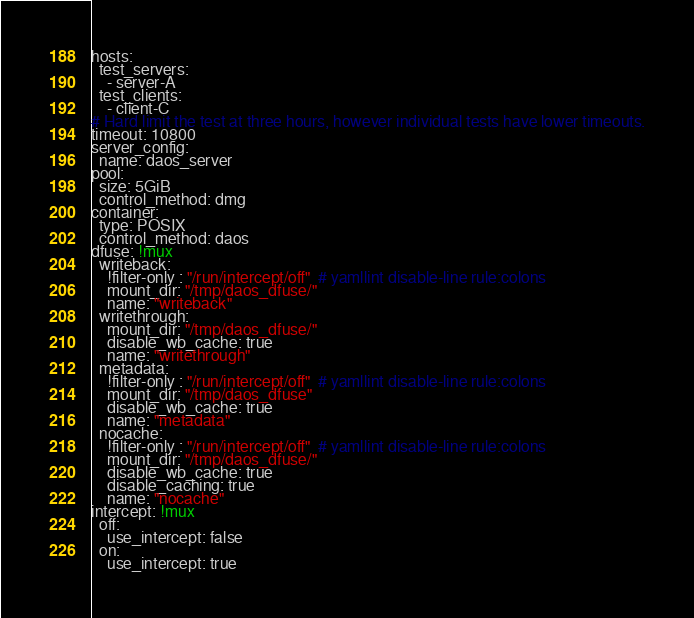Convert code to text. <code><loc_0><loc_0><loc_500><loc_500><_YAML_>hosts:
  test_servers:
    - server-A
  test_clients:
    - client-C
# Hard limit the test at three hours, however individual tests have lower timeouts.
timeout: 10800
server_config:
  name: daos_server
pool:
  size: 5GiB
  control_method: dmg
container:
  type: POSIX
  control_method: daos
dfuse: !mux
  writeback:
    !filter-only : "/run/intercept/off"  # yamllint disable-line rule:colons
    mount_dir: "/tmp/daos_dfuse/"
    name: "writeback"
  writethrough:
    mount_dir: "/tmp/daos_dfuse/"
    disable_wb_cache: true
    name: "writethrough"
  metadata:
    !filter-only : "/run/intercept/off"  # yamllint disable-line rule:colons
    mount_dir: "/tmp/daos_dfuse"
    disable_wb_cache: true
    name: "metadata"
  nocache:
    !filter-only : "/run/intercept/off"  # yamllint disable-line rule:colons
    mount_dir: "/tmp/daos_dfuse/"
    disable_wb_cache: true
    disable_caching: true
    name: "nocache"
intercept: !mux
  off:
    use_intercept: false
  on:
    use_intercept: true
</code> 